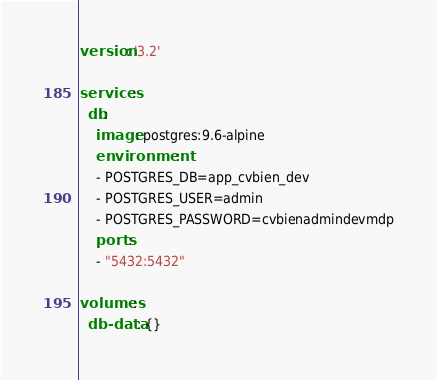<code> <loc_0><loc_0><loc_500><loc_500><_YAML_>version: '3.2'

services:
  db:
    image: postgres:9.6-alpine
    environment:
    - POSTGRES_DB=app_cvbien_dev
    - POSTGRES_USER=admin
    - POSTGRES_PASSWORD=cvbienadmindevmdp
    ports:
    - "5432:5432"

volumes:
  db-data: {}</code> 